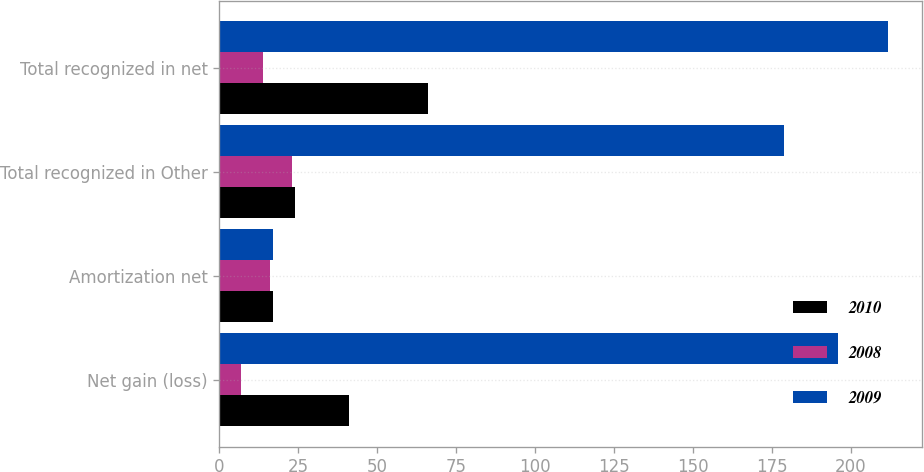<chart> <loc_0><loc_0><loc_500><loc_500><stacked_bar_chart><ecel><fcel>Net gain (loss)<fcel>Amortization net<fcel>Total recognized in Other<fcel>Total recognized in net<nl><fcel>2010<fcel>41<fcel>17<fcel>24<fcel>66<nl><fcel>2008<fcel>7<fcel>16<fcel>23<fcel>14<nl><fcel>2009<fcel>196<fcel>17<fcel>179<fcel>212<nl></chart> 